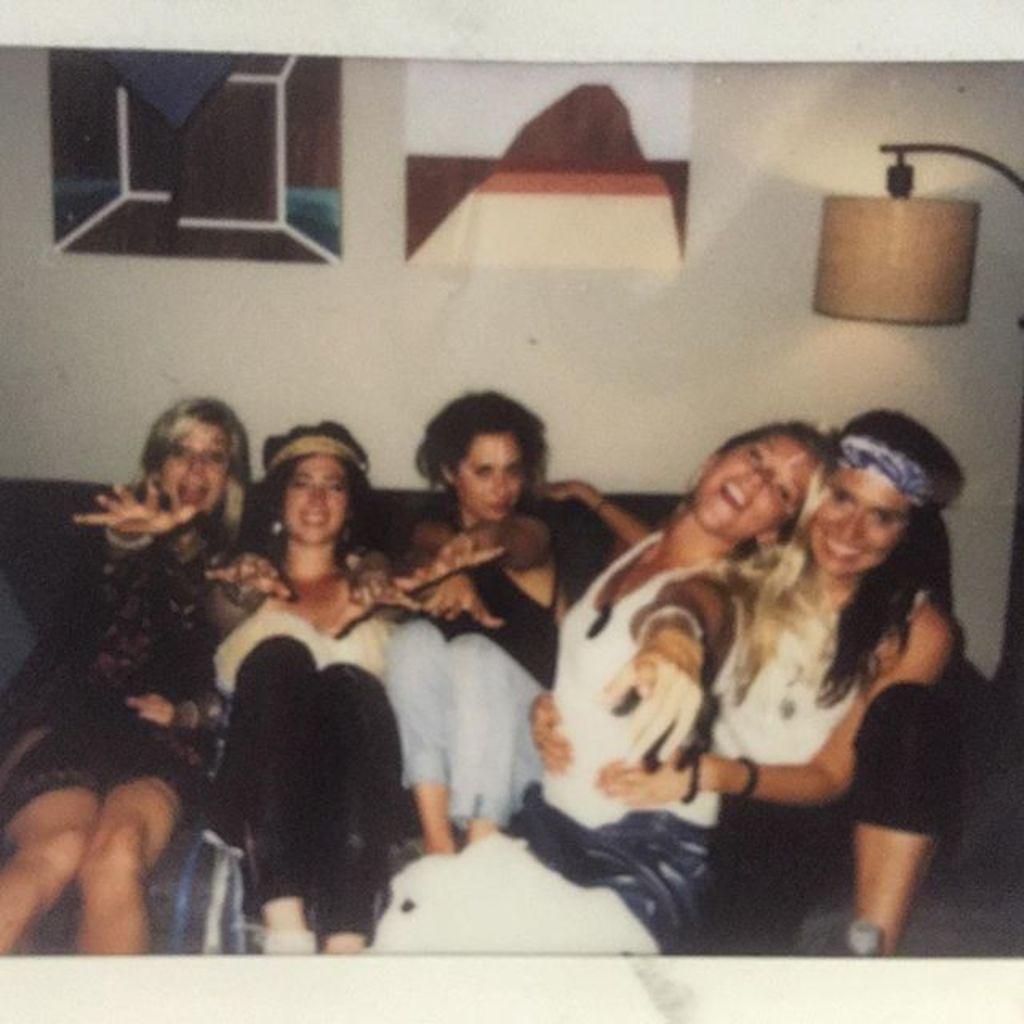Could you give a brief overview of what you see in this image? In this image we can see five girls are sitting on the sofa. There is a lamp on the right side of the image. At the top of the image, we can see frames on the wall. 